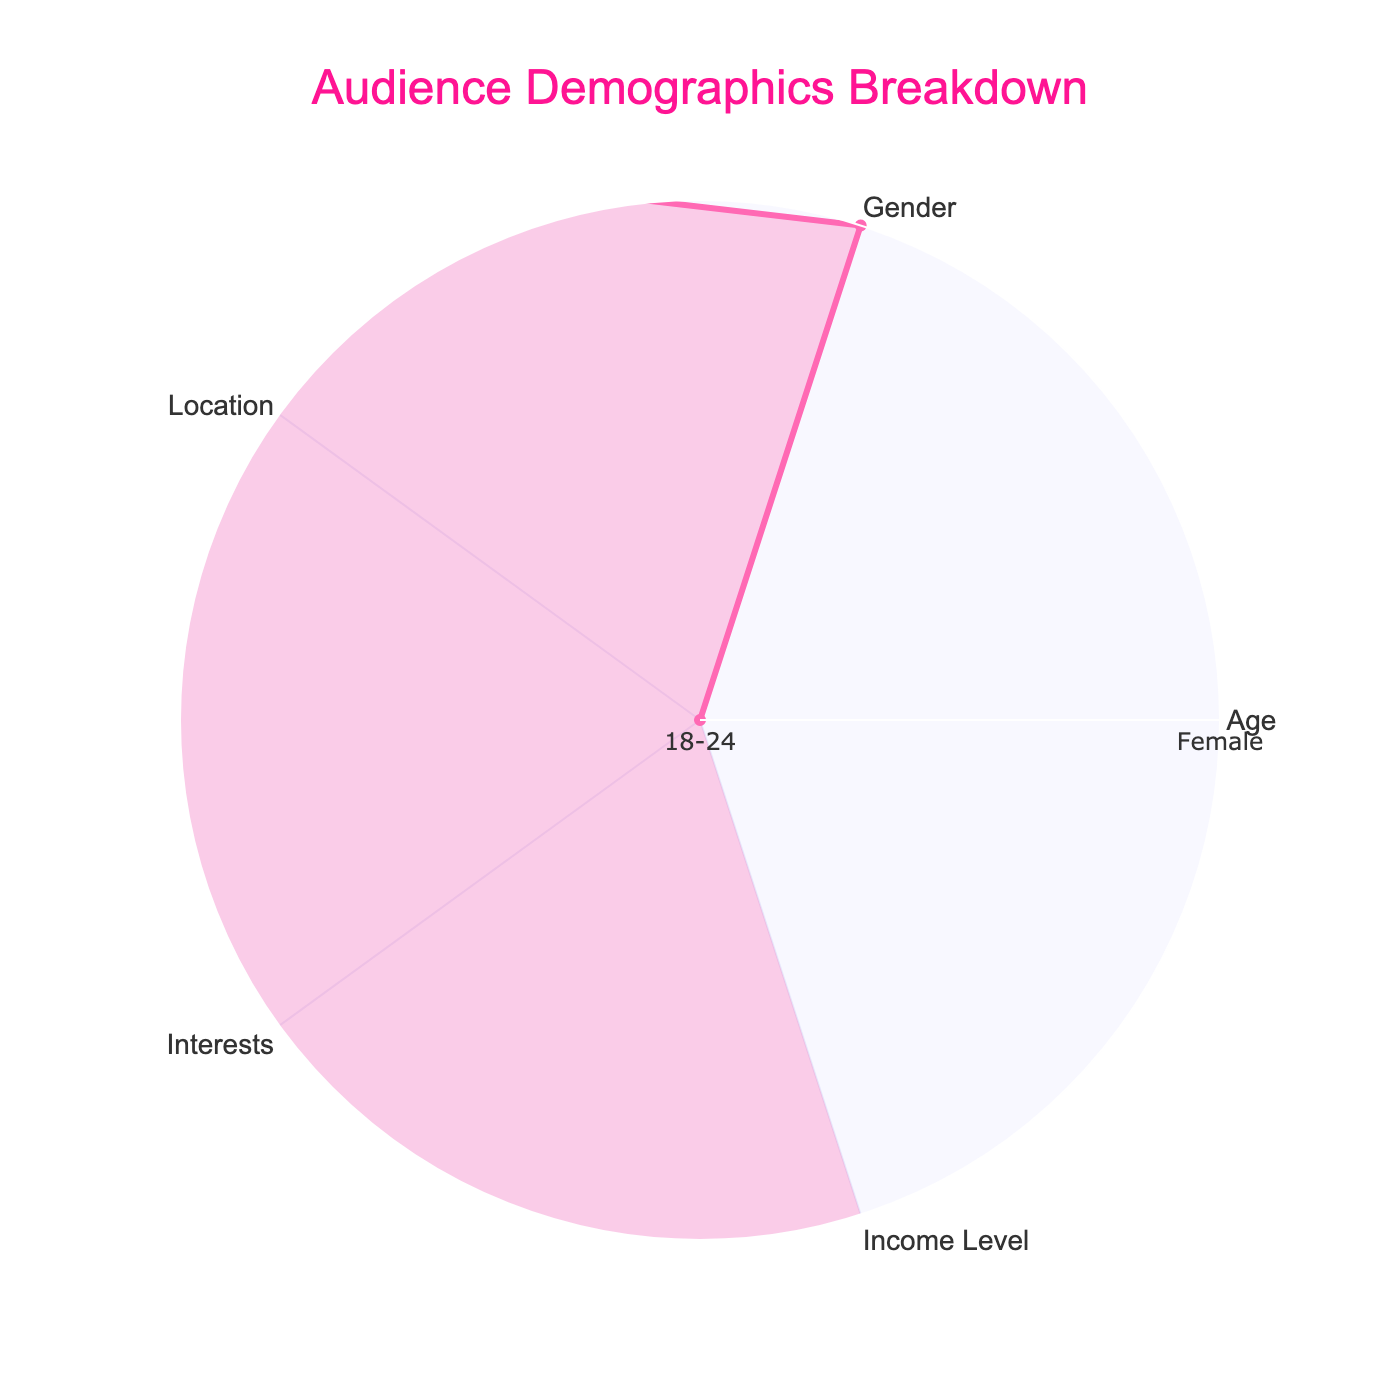What is the title of the figure? The title is displayed prominently at the top of the radar chart.
Answer: Audience Demographics Breakdown What color is used for the lines in the radar chart? The line color can be identified visually from the chart.
Answer: Pink How many segments are used to represent different categories in the radar chart? Count the individual segments or axes in the radar chart.
Answer: Five Which category has the most prominent or highest value in the radar chart? By comparing the lengths of the segments, you can determine which one has the largest value.
Answer: Interests Based on the radar chart, which category appears to have a lower value compared to the others? By comparing the lengths of the segments, you can see which one has a shorter length compared to others.
Answer: Gender If we average the values of Age and Gender, where would this average value lie on the radar chart? First, note the value of Age and Gender, sum them up, and then divide by 2 to get the average. Analyze the position where this average value would lie compared to others.
Answer: In the middle of the plot Between Location and Income Level, which category has a greater value? Compare the lengths or positions of the segments of these two categories in the radar chart.
Answer: Location How does the value for Interests compare to that for Age? Visually inspect and compare the segments representing Interests and Age to see which is larger.
Answer: Interests is higher If you were to sum the values of all categories, how would the resulting value be represented collectively in the radar chart? Adding all segment values provides a cumulative measure. Each segment would contribute to an overall combined length when visualized collectively.
Answer: One full circle around the chart If the trend shown in Interests were to double in its value, what would be its new position in the radar chart? Considering the position of Interests, doubling its length would potentially extend it to twice its current length.
Answer: Beyond the current highest point 